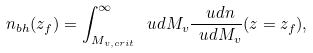<formula> <loc_0><loc_0><loc_500><loc_500>n _ { b h } ( z _ { f } ) = \int _ { M _ { v , c r i t } } ^ { \infty } \ u d M _ { v } \frac { \ u d n } { \ u d M _ { v } } ( z = z _ { f } ) ,</formula> 